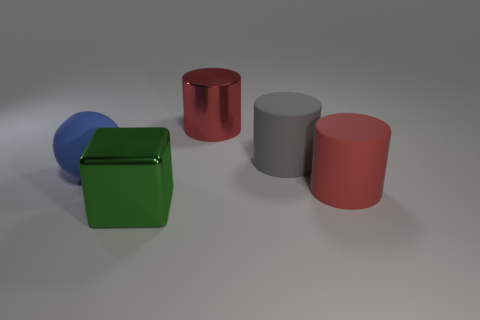Add 4 yellow matte cylinders. How many objects exist? 9 Subtract all cylinders. How many objects are left? 2 Add 4 big metallic cylinders. How many big metallic cylinders are left? 5 Add 2 small matte blocks. How many small matte blocks exist? 2 Subtract 0 cyan spheres. How many objects are left? 5 Subtract all red shiny things. Subtract all matte things. How many objects are left? 1 